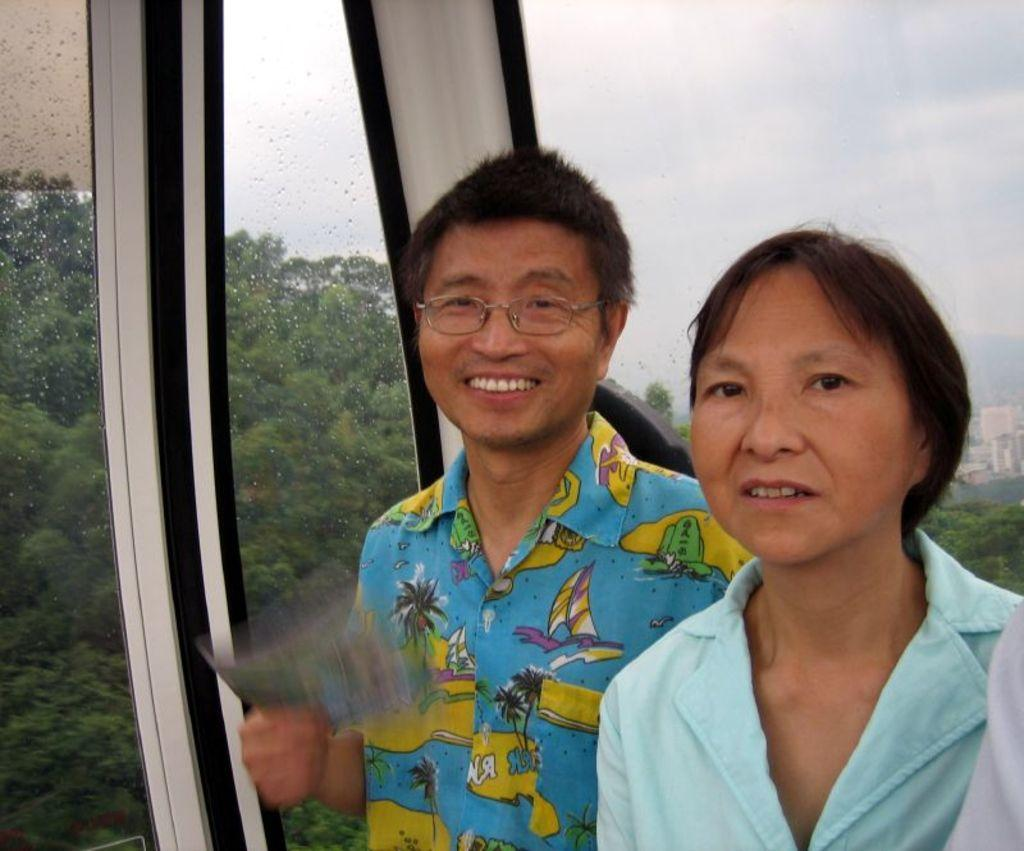How many people are in the image? There are two persons standing in the image. What is the facial expression of the persons in the image? The persons are smiling. What object can be seen in the image? There is a glass in the image. What type of vegetation is visible through a wall in the image? Trees are visible through a wall in the image. What is visible in the sky in the image? Clouds are visible in the sky in the image. What part of the natural environment is visible in the image? The sky is visible in the image. What type of scarf is being used as a harbor in the image? There is no scarf or harbor present in the image. 